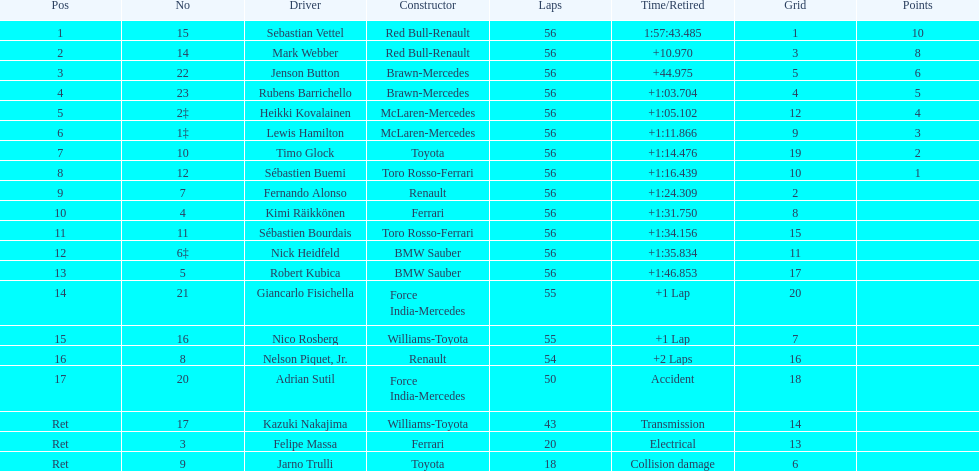Which name is immediately preceding kazuki nakajima on the list? Adrian Sutil. 